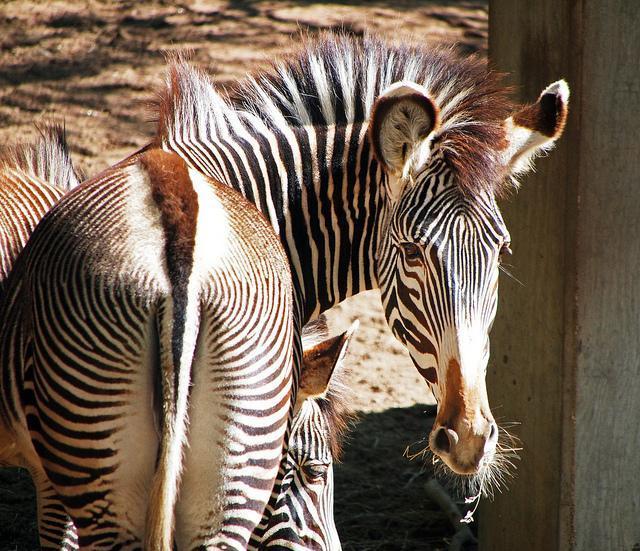How many zebras are visible?
Give a very brief answer. 2. How many people in this photo are skiing?
Give a very brief answer. 0. 